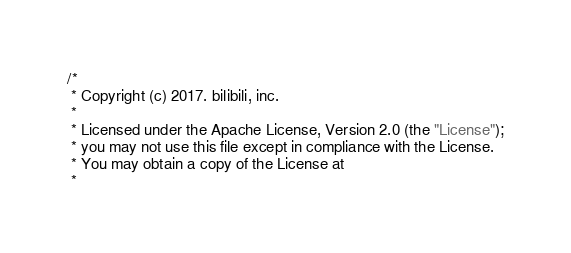<code> <loc_0><loc_0><loc_500><loc_500><_Kotlin_>/*
 * Copyright (c) 2017. bilibili, inc.
 *
 * Licensed under the Apache License, Version 2.0 (the "License");
 * you may not use this file except in compliance with the License.
 * You may obtain a copy of the License at
 *</code> 